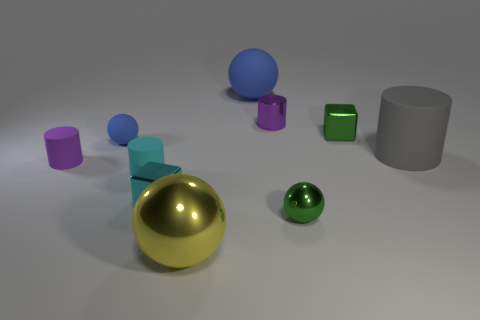Subtract all cylinders. How many objects are left? 6 Add 4 matte things. How many matte things exist? 9 Subtract 0 blue blocks. How many objects are left? 10 Subtract all gray rubber objects. Subtract all small cyan rubber things. How many objects are left? 8 Add 6 green cubes. How many green cubes are left? 7 